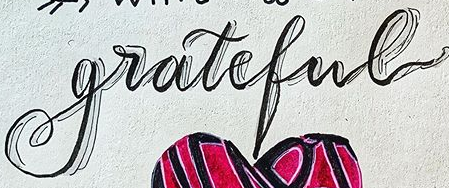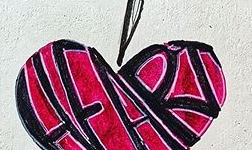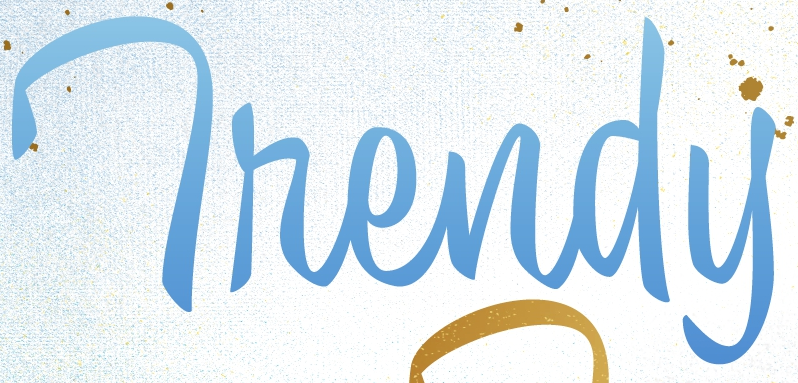Transcribe the words shown in these images in order, separated by a semicolon. grateful; HFART; Thendy 